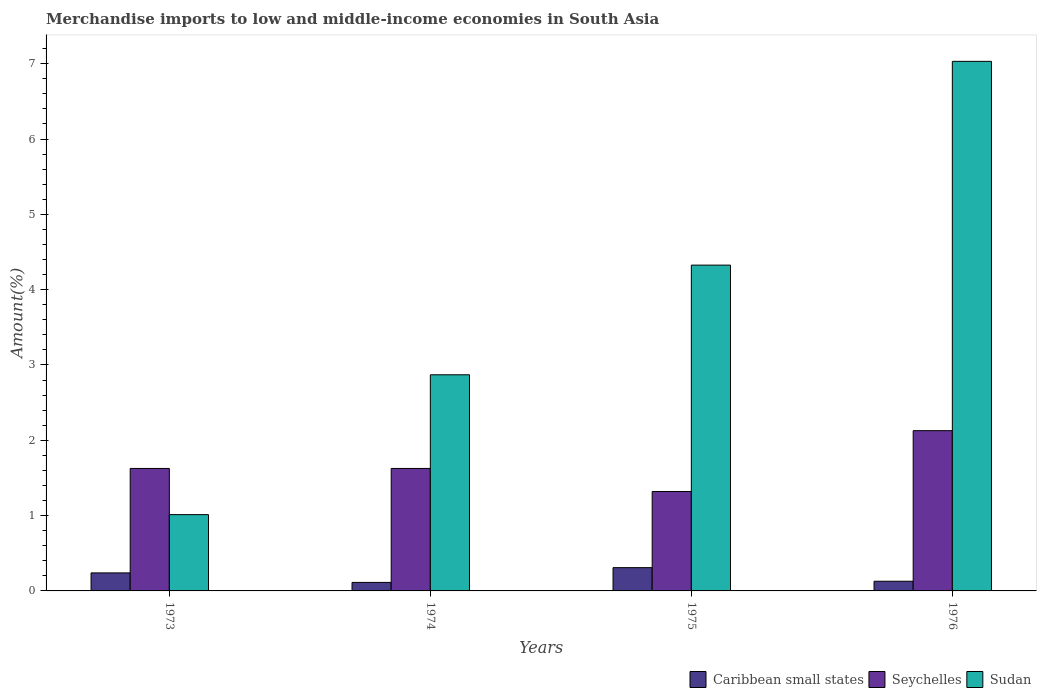How many groups of bars are there?
Provide a succinct answer. 4. Are the number of bars on each tick of the X-axis equal?
Offer a terse response. Yes. How many bars are there on the 4th tick from the right?
Make the answer very short. 3. What is the label of the 2nd group of bars from the left?
Keep it short and to the point. 1974. In how many cases, is the number of bars for a given year not equal to the number of legend labels?
Keep it short and to the point. 0. What is the percentage of amount earned from merchandise imports in Sudan in 1973?
Your response must be concise. 1.01. Across all years, what is the maximum percentage of amount earned from merchandise imports in Sudan?
Your answer should be compact. 7.03. Across all years, what is the minimum percentage of amount earned from merchandise imports in Seychelles?
Make the answer very short. 1.32. In which year was the percentage of amount earned from merchandise imports in Caribbean small states maximum?
Ensure brevity in your answer.  1975. In which year was the percentage of amount earned from merchandise imports in Seychelles minimum?
Provide a short and direct response. 1975. What is the total percentage of amount earned from merchandise imports in Seychelles in the graph?
Offer a very short reply. 6.7. What is the difference between the percentage of amount earned from merchandise imports in Caribbean small states in 1974 and that in 1976?
Give a very brief answer. -0.02. What is the difference between the percentage of amount earned from merchandise imports in Seychelles in 1973 and the percentage of amount earned from merchandise imports in Caribbean small states in 1974?
Provide a short and direct response. 1.51. What is the average percentage of amount earned from merchandise imports in Sudan per year?
Your response must be concise. 3.81. In the year 1976, what is the difference between the percentage of amount earned from merchandise imports in Caribbean small states and percentage of amount earned from merchandise imports in Sudan?
Ensure brevity in your answer.  -6.9. In how many years, is the percentage of amount earned from merchandise imports in Caribbean small states greater than 1.6 %?
Your response must be concise. 0. What is the ratio of the percentage of amount earned from merchandise imports in Caribbean small states in 1975 to that in 1976?
Give a very brief answer. 2.4. Is the percentage of amount earned from merchandise imports in Caribbean small states in 1974 less than that in 1976?
Provide a succinct answer. Yes. What is the difference between the highest and the second highest percentage of amount earned from merchandise imports in Seychelles?
Offer a very short reply. 0.5. What is the difference between the highest and the lowest percentage of amount earned from merchandise imports in Seychelles?
Offer a terse response. 0.81. What does the 2nd bar from the left in 1976 represents?
Offer a very short reply. Seychelles. What does the 3rd bar from the right in 1975 represents?
Your answer should be very brief. Caribbean small states. Is it the case that in every year, the sum of the percentage of amount earned from merchandise imports in Sudan and percentage of amount earned from merchandise imports in Caribbean small states is greater than the percentage of amount earned from merchandise imports in Seychelles?
Make the answer very short. No. How many bars are there?
Make the answer very short. 12. Are all the bars in the graph horizontal?
Give a very brief answer. No. What is the difference between two consecutive major ticks on the Y-axis?
Your answer should be compact. 1. Does the graph contain grids?
Your answer should be compact. No. Where does the legend appear in the graph?
Give a very brief answer. Bottom right. How many legend labels are there?
Ensure brevity in your answer.  3. How are the legend labels stacked?
Your answer should be very brief. Horizontal. What is the title of the graph?
Make the answer very short. Merchandise imports to low and middle-income economies in South Asia. What is the label or title of the X-axis?
Ensure brevity in your answer.  Years. What is the label or title of the Y-axis?
Your answer should be compact. Amount(%). What is the Amount(%) in Caribbean small states in 1973?
Your answer should be compact. 0.24. What is the Amount(%) in Seychelles in 1973?
Offer a very short reply. 1.63. What is the Amount(%) in Sudan in 1973?
Your answer should be very brief. 1.01. What is the Amount(%) in Caribbean small states in 1974?
Provide a short and direct response. 0.11. What is the Amount(%) of Seychelles in 1974?
Provide a short and direct response. 1.63. What is the Amount(%) in Sudan in 1974?
Your answer should be very brief. 2.87. What is the Amount(%) in Caribbean small states in 1975?
Provide a short and direct response. 0.31. What is the Amount(%) of Seychelles in 1975?
Provide a short and direct response. 1.32. What is the Amount(%) in Sudan in 1975?
Provide a short and direct response. 4.33. What is the Amount(%) of Caribbean small states in 1976?
Make the answer very short. 0.13. What is the Amount(%) of Seychelles in 1976?
Offer a terse response. 2.13. What is the Amount(%) of Sudan in 1976?
Offer a very short reply. 7.03. Across all years, what is the maximum Amount(%) of Caribbean small states?
Provide a short and direct response. 0.31. Across all years, what is the maximum Amount(%) in Seychelles?
Give a very brief answer. 2.13. Across all years, what is the maximum Amount(%) of Sudan?
Provide a short and direct response. 7.03. Across all years, what is the minimum Amount(%) of Caribbean small states?
Your answer should be compact. 0.11. Across all years, what is the minimum Amount(%) in Seychelles?
Give a very brief answer. 1.32. Across all years, what is the minimum Amount(%) in Sudan?
Provide a short and direct response. 1.01. What is the total Amount(%) of Caribbean small states in the graph?
Provide a succinct answer. 0.79. What is the total Amount(%) in Seychelles in the graph?
Your answer should be compact. 6.7. What is the total Amount(%) of Sudan in the graph?
Provide a short and direct response. 15.24. What is the difference between the Amount(%) of Caribbean small states in 1973 and that in 1974?
Your answer should be compact. 0.13. What is the difference between the Amount(%) of Seychelles in 1973 and that in 1974?
Your response must be concise. 0. What is the difference between the Amount(%) of Sudan in 1973 and that in 1974?
Your answer should be very brief. -1.86. What is the difference between the Amount(%) of Caribbean small states in 1973 and that in 1975?
Ensure brevity in your answer.  -0.07. What is the difference between the Amount(%) of Seychelles in 1973 and that in 1975?
Give a very brief answer. 0.31. What is the difference between the Amount(%) of Sudan in 1973 and that in 1975?
Your answer should be very brief. -3.31. What is the difference between the Amount(%) in Caribbean small states in 1973 and that in 1976?
Offer a very short reply. 0.11. What is the difference between the Amount(%) in Seychelles in 1973 and that in 1976?
Keep it short and to the point. -0.5. What is the difference between the Amount(%) in Sudan in 1973 and that in 1976?
Give a very brief answer. -6.02. What is the difference between the Amount(%) in Caribbean small states in 1974 and that in 1975?
Give a very brief answer. -0.2. What is the difference between the Amount(%) in Seychelles in 1974 and that in 1975?
Offer a terse response. 0.31. What is the difference between the Amount(%) of Sudan in 1974 and that in 1975?
Your answer should be very brief. -1.46. What is the difference between the Amount(%) in Caribbean small states in 1974 and that in 1976?
Ensure brevity in your answer.  -0.02. What is the difference between the Amount(%) in Seychelles in 1974 and that in 1976?
Make the answer very short. -0.5. What is the difference between the Amount(%) of Sudan in 1974 and that in 1976?
Give a very brief answer. -4.16. What is the difference between the Amount(%) in Caribbean small states in 1975 and that in 1976?
Offer a very short reply. 0.18. What is the difference between the Amount(%) of Seychelles in 1975 and that in 1976?
Your answer should be compact. -0.81. What is the difference between the Amount(%) in Sudan in 1975 and that in 1976?
Make the answer very short. -2.71. What is the difference between the Amount(%) of Caribbean small states in 1973 and the Amount(%) of Seychelles in 1974?
Your answer should be compact. -1.39. What is the difference between the Amount(%) in Caribbean small states in 1973 and the Amount(%) in Sudan in 1974?
Your answer should be very brief. -2.63. What is the difference between the Amount(%) in Seychelles in 1973 and the Amount(%) in Sudan in 1974?
Keep it short and to the point. -1.24. What is the difference between the Amount(%) in Caribbean small states in 1973 and the Amount(%) in Seychelles in 1975?
Your answer should be very brief. -1.08. What is the difference between the Amount(%) in Caribbean small states in 1973 and the Amount(%) in Sudan in 1975?
Provide a short and direct response. -4.09. What is the difference between the Amount(%) of Seychelles in 1973 and the Amount(%) of Sudan in 1975?
Your answer should be compact. -2.7. What is the difference between the Amount(%) in Caribbean small states in 1973 and the Amount(%) in Seychelles in 1976?
Give a very brief answer. -1.89. What is the difference between the Amount(%) of Caribbean small states in 1973 and the Amount(%) of Sudan in 1976?
Provide a short and direct response. -6.79. What is the difference between the Amount(%) of Seychelles in 1973 and the Amount(%) of Sudan in 1976?
Give a very brief answer. -5.41. What is the difference between the Amount(%) of Caribbean small states in 1974 and the Amount(%) of Seychelles in 1975?
Provide a short and direct response. -1.21. What is the difference between the Amount(%) of Caribbean small states in 1974 and the Amount(%) of Sudan in 1975?
Ensure brevity in your answer.  -4.21. What is the difference between the Amount(%) in Seychelles in 1974 and the Amount(%) in Sudan in 1975?
Keep it short and to the point. -2.7. What is the difference between the Amount(%) in Caribbean small states in 1974 and the Amount(%) in Seychelles in 1976?
Offer a terse response. -2.01. What is the difference between the Amount(%) in Caribbean small states in 1974 and the Amount(%) in Sudan in 1976?
Ensure brevity in your answer.  -6.92. What is the difference between the Amount(%) of Seychelles in 1974 and the Amount(%) of Sudan in 1976?
Your answer should be compact. -5.41. What is the difference between the Amount(%) of Caribbean small states in 1975 and the Amount(%) of Seychelles in 1976?
Your response must be concise. -1.82. What is the difference between the Amount(%) of Caribbean small states in 1975 and the Amount(%) of Sudan in 1976?
Give a very brief answer. -6.72. What is the difference between the Amount(%) of Seychelles in 1975 and the Amount(%) of Sudan in 1976?
Give a very brief answer. -5.71. What is the average Amount(%) of Caribbean small states per year?
Provide a short and direct response. 0.2. What is the average Amount(%) in Seychelles per year?
Your answer should be compact. 1.68. What is the average Amount(%) of Sudan per year?
Your answer should be compact. 3.81. In the year 1973, what is the difference between the Amount(%) of Caribbean small states and Amount(%) of Seychelles?
Provide a short and direct response. -1.39. In the year 1973, what is the difference between the Amount(%) of Caribbean small states and Amount(%) of Sudan?
Provide a short and direct response. -0.77. In the year 1973, what is the difference between the Amount(%) in Seychelles and Amount(%) in Sudan?
Offer a terse response. 0.61. In the year 1974, what is the difference between the Amount(%) of Caribbean small states and Amount(%) of Seychelles?
Keep it short and to the point. -1.51. In the year 1974, what is the difference between the Amount(%) in Caribbean small states and Amount(%) in Sudan?
Your answer should be very brief. -2.76. In the year 1974, what is the difference between the Amount(%) of Seychelles and Amount(%) of Sudan?
Keep it short and to the point. -1.24. In the year 1975, what is the difference between the Amount(%) in Caribbean small states and Amount(%) in Seychelles?
Keep it short and to the point. -1.01. In the year 1975, what is the difference between the Amount(%) of Caribbean small states and Amount(%) of Sudan?
Give a very brief answer. -4.02. In the year 1975, what is the difference between the Amount(%) in Seychelles and Amount(%) in Sudan?
Your answer should be compact. -3.01. In the year 1976, what is the difference between the Amount(%) in Caribbean small states and Amount(%) in Seychelles?
Make the answer very short. -2. In the year 1976, what is the difference between the Amount(%) in Caribbean small states and Amount(%) in Sudan?
Make the answer very short. -6.9. In the year 1976, what is the difference between the Amount(%) of Seychelles and Amount(%) of Sudan?
Your response must be concise. -4.9. What is the ratio of the Amount(%) of Caribbean small states in 1973 to that in 1974?
Offer a very short reply. 2.12. What is the ratio of the Amount(%) in Seychelles in 1973 to that in 1974?
Make the answer very short. 1. What is the ratio of the Amount(%) of Sudan in 1973 to that in 1974?
Offer a very short reply. 0.35. What is the ratio of the Amount(%) of Caribbean small states in 1973 to that in 1975?
Offer a very short reply. 0.77. What is the ratio of the Amount(%) of Seychelles in 1973 to that in 1975?
Your response must be concise. 1.23. What is the ratio of the Amount(%) in Sudan in 1973 to that in 1975?
Offer a terse response. 0.23. What is the ratio of the Amount(%) in Caribbean small states in 1973 to that in 1976?
Your response must be concise. 1.86. What is the ratio of the Amount(%) in Seychelles in 1973 to that in 1976?
Give a very brief answer. 0.76. What is the ratio of the Amount(%) of Sudan in 1973 to that in 1976?
Keep it short and to the point. 0.14. What is the ratio of the Amount(%) in Caribbean small states in 1974 to that in 1975?
Keep it short and to the point. 0.37. What is the ratio of the Amount(%) in Seychelles in 1974 to that in 1975?
Provide a succinct answer. 1.23. What is the ratio of the Amount(%) in Sudan in 1974 to that in 1975?
Your response must be concise. 0.66. What is the ratio of the Amount(%) in Caribbean small states in 1974 to that in 1976?
Keep it short and to the point. 0.88. What is the ratio of the Amount(%) in Seychelles in 1974 to that in 1976?
Your response must be concise. 0.76. What is the ratio of the Amount(%) of Sudan in 1974 to that in 1976?
Give a very brief answer. 0.41. What is the ratio of the Amount(%) in Caribbean small states in 1975 to that in 1976?
Your answer should be compact. 2.4. What is the ratio of the Amount(%) of Seychelles in 1975 to that in 1976?
Your response must be concise. 0.62. What is the ratio of the Amount(%) of Sudan in 1975 to that in 1976?
Make the answer very short. 0.62. What is the difference between the highest and the second highest Amount(%) of Caribbean small states?
Provide a succinct answer. 0.07. What is the difference between the highest and the second highest Amount(%) in Seychelles?
Offer a very short reply. 0.5. What is the difference between the highest and the second highest Amount(%) in Sudan?
Your answer should be compact. 2.71. What is the difference between the highest and the lowest Amount(%) in Caribbean small states?
Your answer should be very brief. 0.2. What is the difference between the highest and the lowest Amount(%) of Seychelles?
Provide a succinct answer. 0.81. What is the difference between the highest and the lowest Amount(%) in Sudan?
Keep it short and to the point. 6.02. 